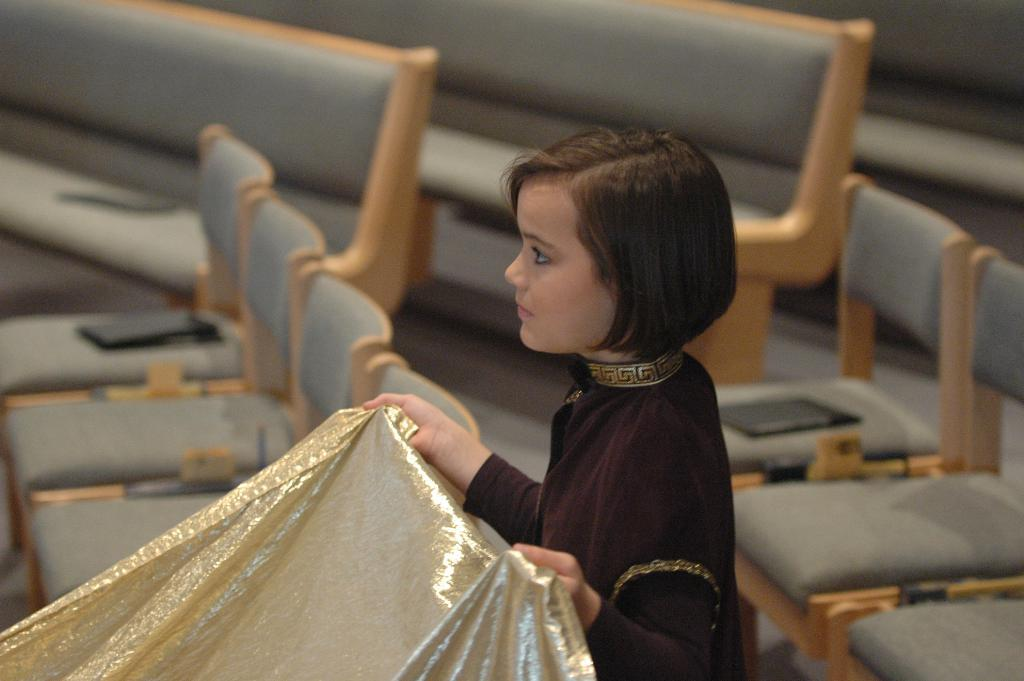Who is present in the image? There is a woman in the image. What is the woman holding in her hands? The woman is holding a cloth with her hands. What type of furniture can be seen in the image? There are chairs in the image. What type of wilderness can be seen in the background of the image? There is no wilderness visible in the image; it is focused on the woman and the chairs. 